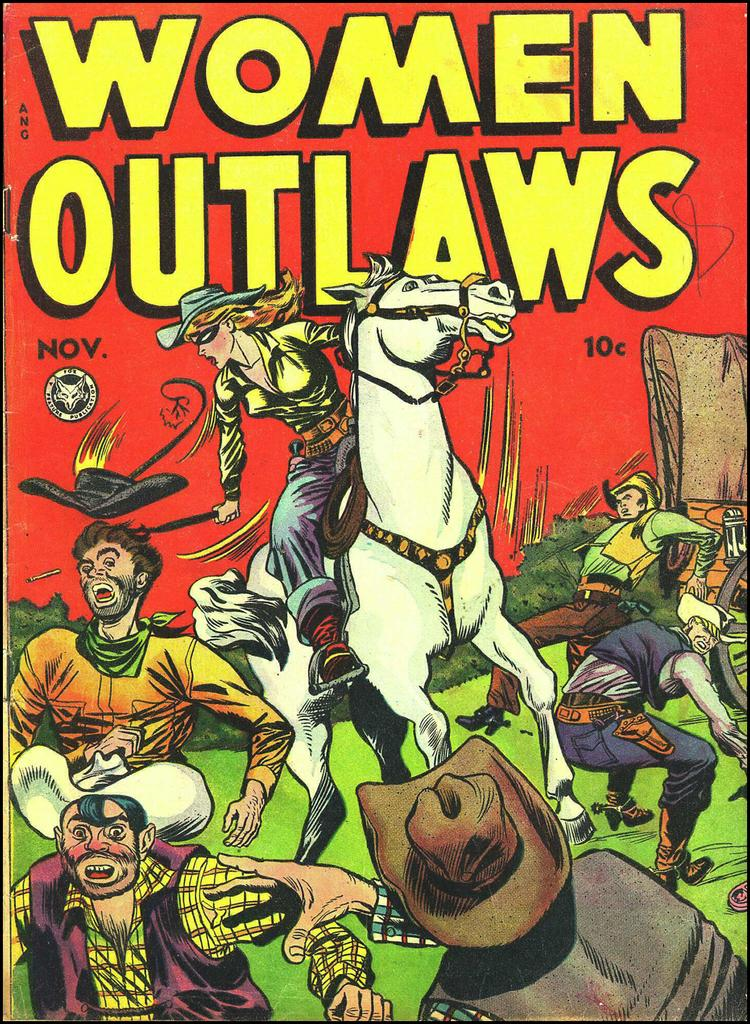<image>
Offer a succinct explanation of the picture presented. Women Outlaws Nov 10c magazine with a horse on the front. 